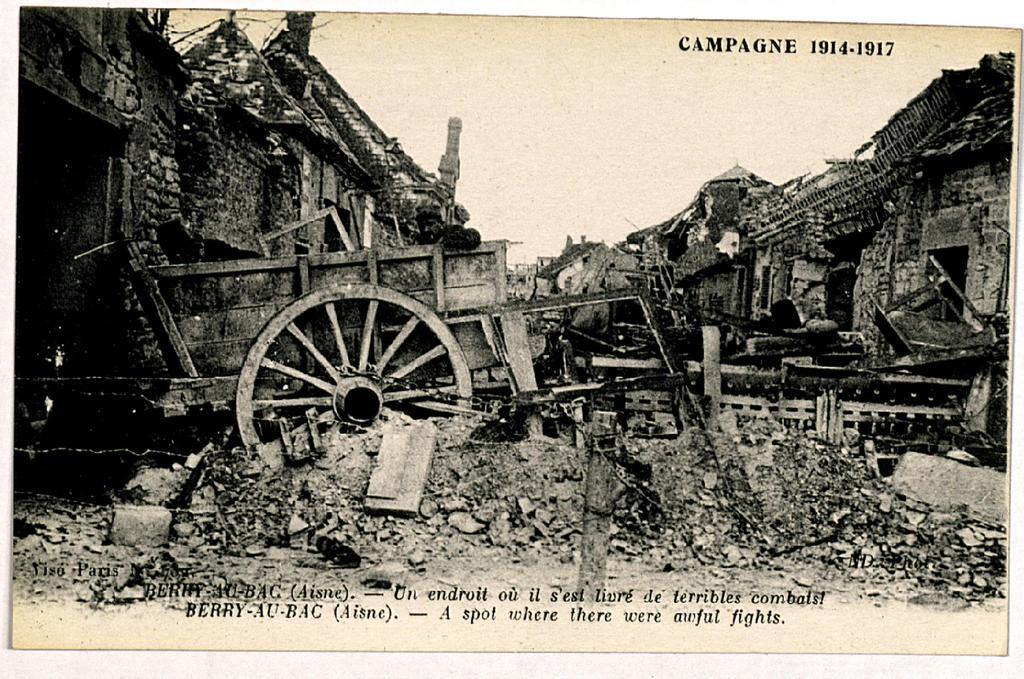What is the color scheme of the image? The image is black and white. What type of structures can be seen in the image? There are houses in the image. What object with a circular shape is present in the image? There is a wheel in the image. Is there any text visible in the image? Yes, there is text written on the wheel. Can you tell me how many guns are visible in the image? There are no guns present in the image. What type of education is being taught in the image? There is no indication of education being taught in the image. 